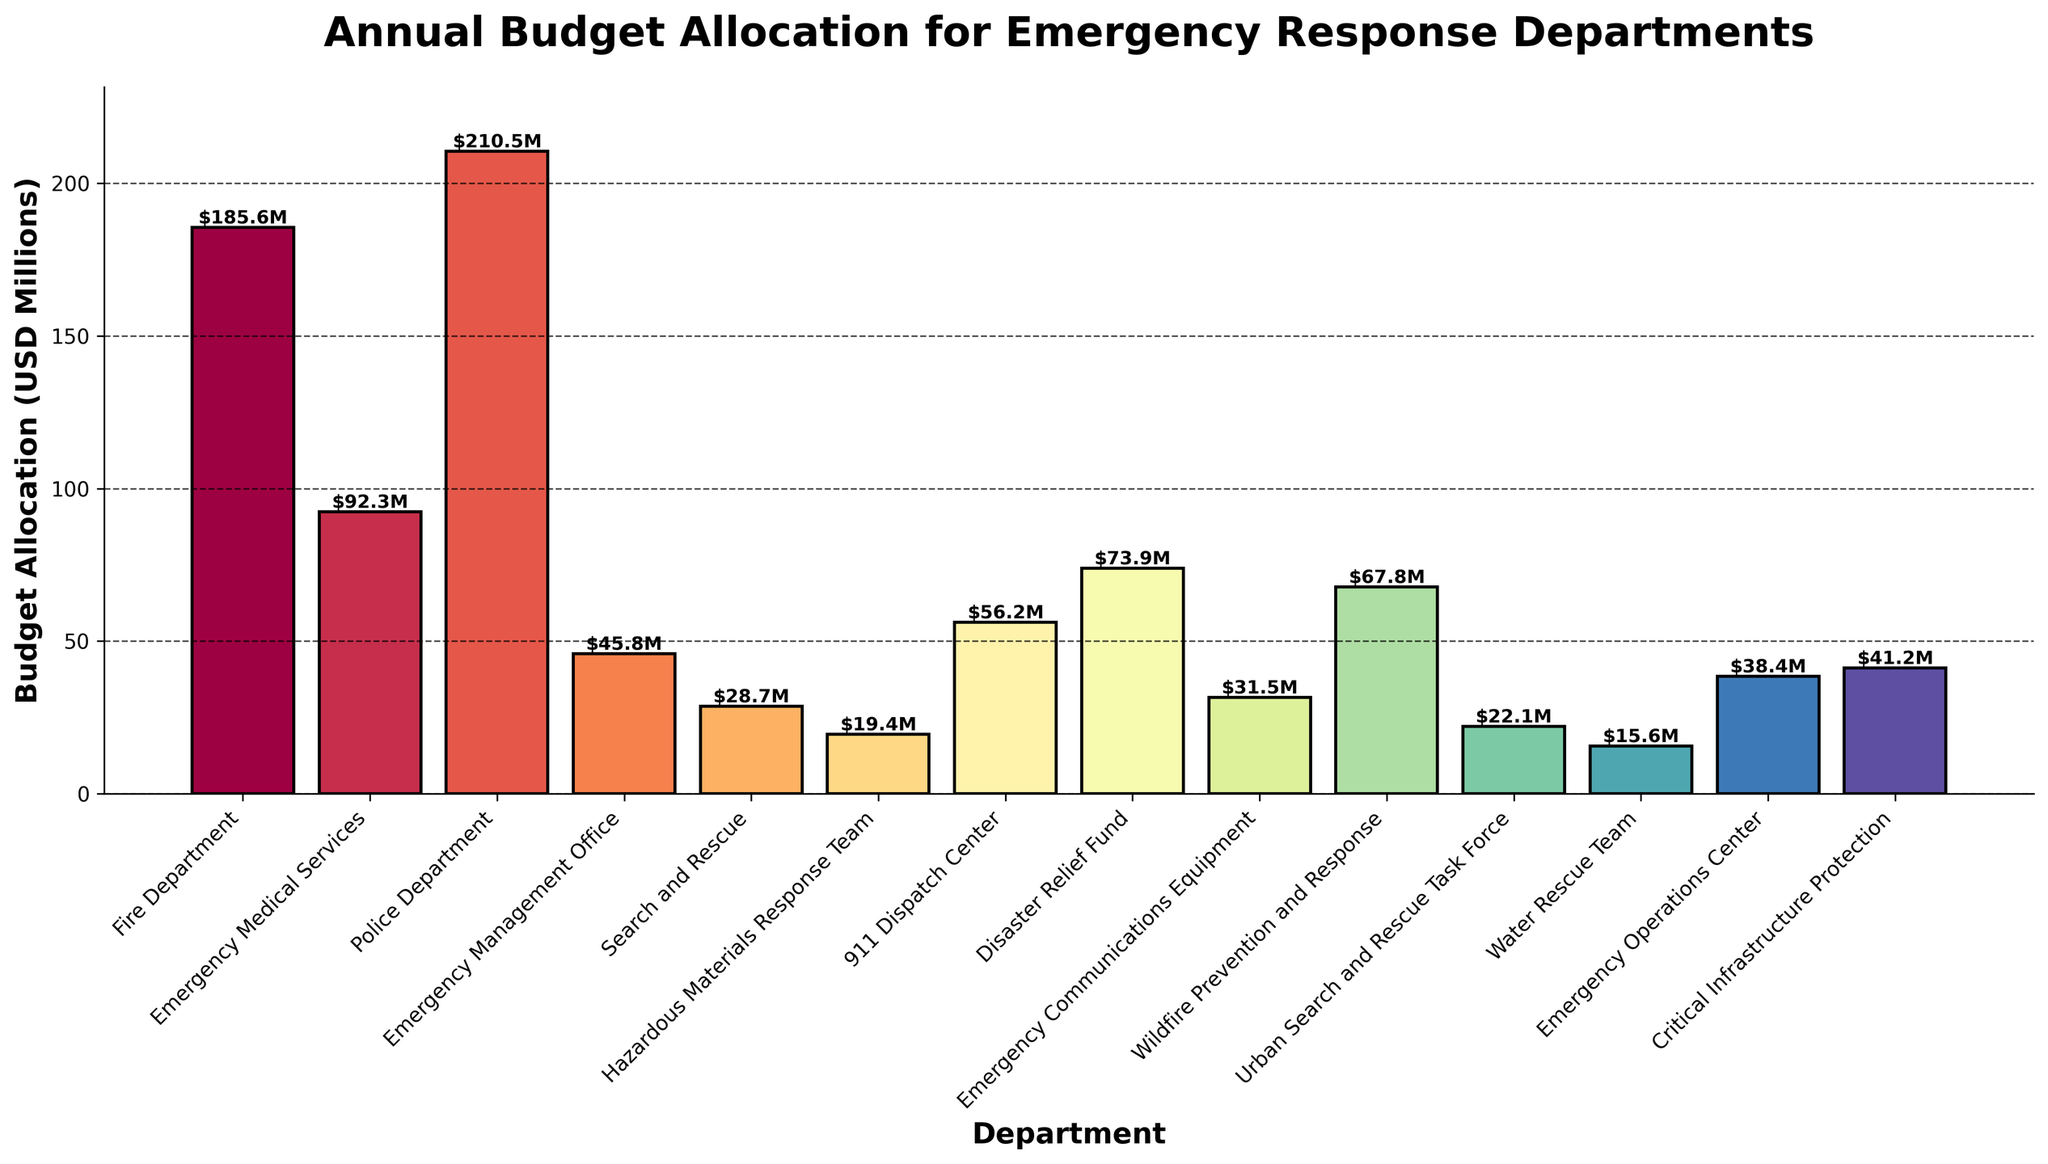How much more is the budget allocation for the Police Department compared to the Fire Department? The budget allocation for the Police Department is $210.5M, while the Fire Department has a budget of $185.6M. The difference is $210.5M - $185.6M = $24.9M.
Answer: $24.9M Which department has the smallest budget, and how much is it? The smallest budget is for the Water Rescue Team, which has a budget allocation of $15.6M.
Answer: Water Rescue Team, $15.6M What is the total budget allocation for Search and Rescue, Hazardous Materials Response Team, and Wildfire Prevention and Response combined? Adding the budgets for these departments: $28.7M (Search and Rescue) + $19.4M (Hazardous Materials Response Team) + $67.8M (Wildfire Prevention and Response) = $115.9M.
Answer: $115.9M Compare the budget allocation between the 911 Dispatch Center and Emergency Communications Equipment. The 911 Dispatch Center has a budget of $56.2M, while Emergency Communications Equipment has $31.5M. $56.2M is greater than $31.5M by $24.7M.
Answer: 911 Dispatch Center has $24.7M more What's the budget allocation range among all departments? The highest budget allocation is for the Police Department ($210.5M) and the lowest is for the Water Rescue Team ($15.6M). The range is $210.5M - $15.6M = $194.9M.
Answer: $194.9M What’s the average budget allocation across all departments? The total sum of all budget allocations is $928M, and there are 14 departments. The average budget allocation is $928M / 14 = $66.3M.
Answer: $66.3M Which department has a budget allocation closest to the average budget allocation? The average budget allocation is $66.3M. Wildfire Prevention and Response, with a budget of $67.8M, is closest to the average.
Answer: Wildfire Prevention and Response ($67.8M) How does the budget allocation for Disaster Relief Fund compare to the combined budgets of the Emergency Operations Center and Critical Infrastructure Protection? The Disaster Relief Fund has a budget of $73.9M. The combined budget for the Emergency Operations Center ($38.4M) and Critical Infrastructure Protection ($41.2M) is $38.4M + $41.2M = $79.6M. The combined budget is $5.7M more than the Disaster Relief Fund.
Answer: Combined budget is $5.7M more In terms of budget allocation, which department is smaller than the Emergency Medical Services but larger than the Emergency Operations Center? Emergency Medical Services has a budget of $92.3M, while the Emergency Operations Center has $38.4M. The Disaster Relief Fund, with a budget of $73.9M, falls between these two.
Answer: Disaster Relief Fund ($73.9M) 